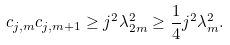<formula> <loc_0><loc_0><loc_500><loc_500>c _ { j , m } c _ { j , m + 1 } \geq j ^ { 2 } \lambda _ { 2 m } ^ { 2 } \geq \frac { 1 } { 4 } j ^ { 2 } \lambda _ { m } ^ { 2 } .</formula> 